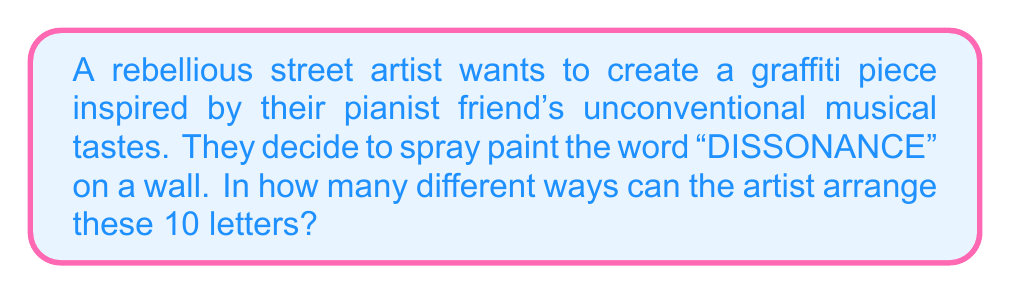Could you help me with this problem? Let's approach this step-by-step:

1) First, we need to count the total number of letters in "DISSONANCE":
   There are 10 letters in total.

2) Next, we need to identify the repeated letters:
   D appears 1 time
   I appears 1 time
   S appears 2 times
   O appears 1 time
   N appears 2 times
   A appears 1 time
   C appears 1 time
   E appears 1 time

3) If all letters were different, we would have 10! arrangements. However, since there are repeated letters, we need to account for these repetitions.

4) For each repeated letter, we need to divide by the factorial of its frequency to avoid overcounting:
   - For S (appears 2 times): divide by 2!
   - For N (appears 2 times): divide by 2!

5) Therefore, the total number of unique arrangements is:

   $$\frac{10!}{2! \cdot 2!}$$

6) Let's calculate this:
   $$\frac{10!}{2! \cdot 2!} = \frac{3,628,800}{4} = 907,200$$

Thus, there are 907,200 different ways to arrange the letters of "DISSONANCE" on the wall.
Answer: 907,200 